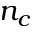Convert formula to latex. <formula><loc_0><loc_0><loc_500><loc_500>n _ { c }</formula> 